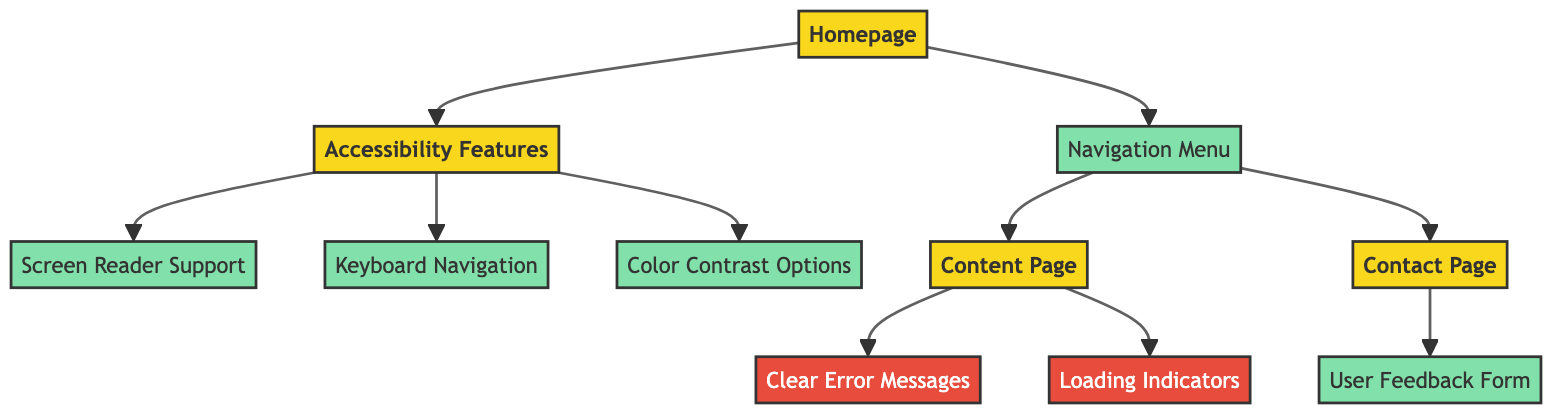What is the starting point of the user journey? The starting point of the user journey is the "Homepage" as indicated by its central position in the diagram.
Answer: Homepage How many interaction nodes are there in the diagram? Counting the nodes that are classified as interactions, we find five nodes: "Navigation Menu," "Screen Reader Support," "Keyboard Navigation," "Contrast Options," and "User Feedback Form."
Answer: 5 What pages can be accessed directly from the navigation menu? The navigation menu leads directly to two pages: "Content Page" and "Contact Page," as shown by the arrows stemming from the navigation menu node.
Answer: Content Page, Contact Page Which barrier is associated with the content page? The content page has two associated barriers: "Clear Error Messages" and "Loading Indicators," both indicated by arrows leading from the content page node to these barrier nodes.
Answer: Clear Error Messages, Loading Indicators Which node provides support for screen readers? The node labeled "Screen Reader Support" is specifically designated for providing support for screen readers, originating from the "Accessibility Features" page.
Answer: Screen Reader Support What is the relationship between the "Accessibility Features" and the "Screen Reader Support"? "Accessibility Features" directly leads to "Screen Reader Support," indicating that screen reader support is a component of the accessibility features offered on the website.
Answer: Direct connection How many barriers are present in total in the diagram? There are two barriers present in the diagram, represented by the nodes "Clear Error Messages" and "Loading Indicators," which are both classified under barriers.
Answer: 2 What type of node is "Contact Page"? The "Contact Page" is classified as a page, distinguished from interactions and barriers of the diagram by its color and labeling in the flowchart.
Answer: Page Which navigation step leads to "User Feedback Form"? The step leading to the "User Feedback Form" is the "Contact Page," as the diagram shows a direct interaction arrow pointing from "Contact Page" to "User Feedback Form."
Answer: Contact Page 